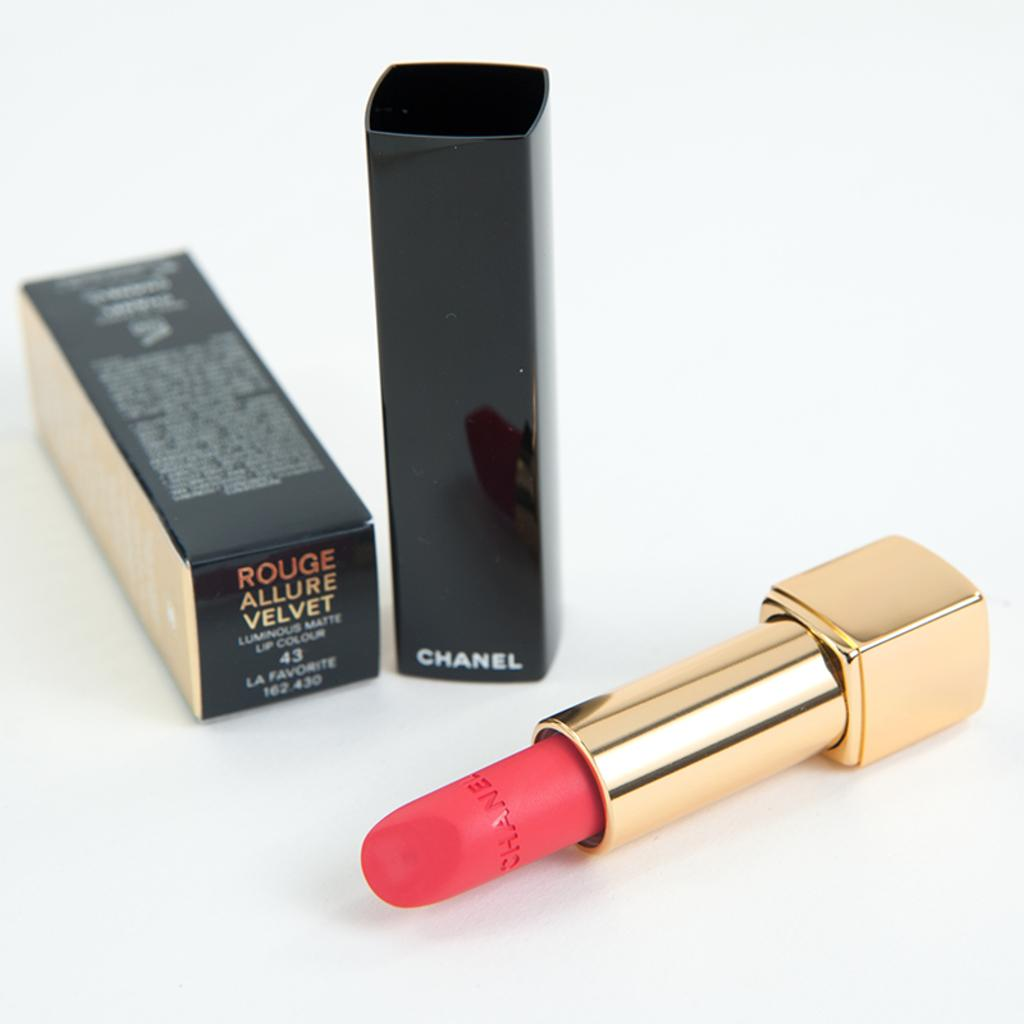What type of cosmetic product is in the image? There is lipstick in the image. What other object can be seen in the image? There is a carton in the image. Where are the lipstick and carton located? Both objects are placed on a table. What is the history of the seat in the image? There is no seat present in the image; it only features lipstick and a carton. 